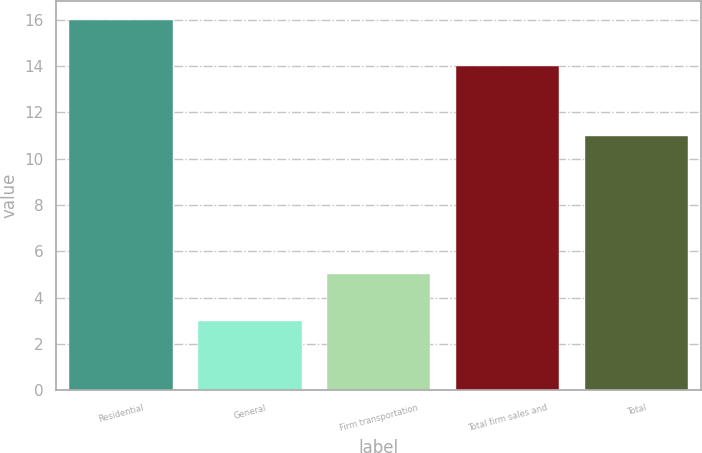Convert chart to OTSL. <chart><loc_0><loc_0><loc_500><loc_500><bar_chart><fcel>Residential<fcel>General<fcel>Firm transportation<fcel>Total firm sales and<fcel>Total<nl><fcel>16<fcel>3<fcel>5<fcel>14<fcel>11<nl></chart> 